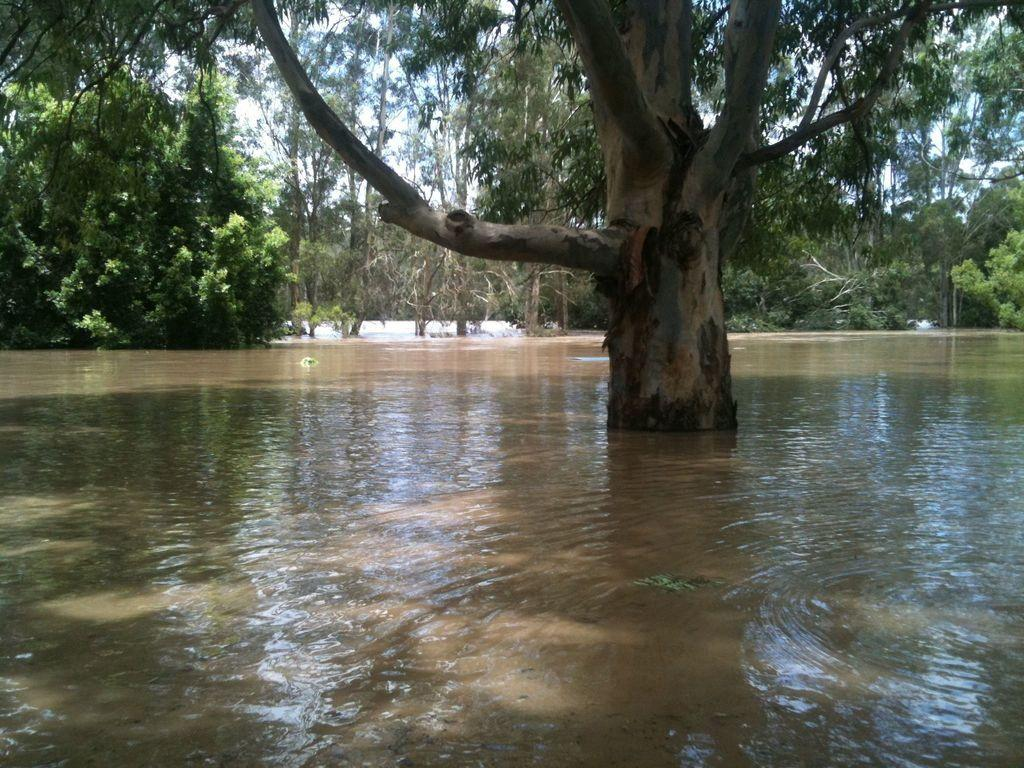What type of natural environment is depicted in the image? The image features trees and water, suggesting a natural setting such as a forest or park. Can you describe the water in the image? The water is visible in the image, but its specific characteristics are not mentioned in the provided facts. How does the presence of trees and water contribute to the overall atmosphere of the image? The presence of trees and water creates a serene and peaceful atmosphere in the image. What type of game is being played in the image? There is no game present in the image; it features trees and water. What type of home can be seen in the image? There is no home present in the image; it features trees and water. 